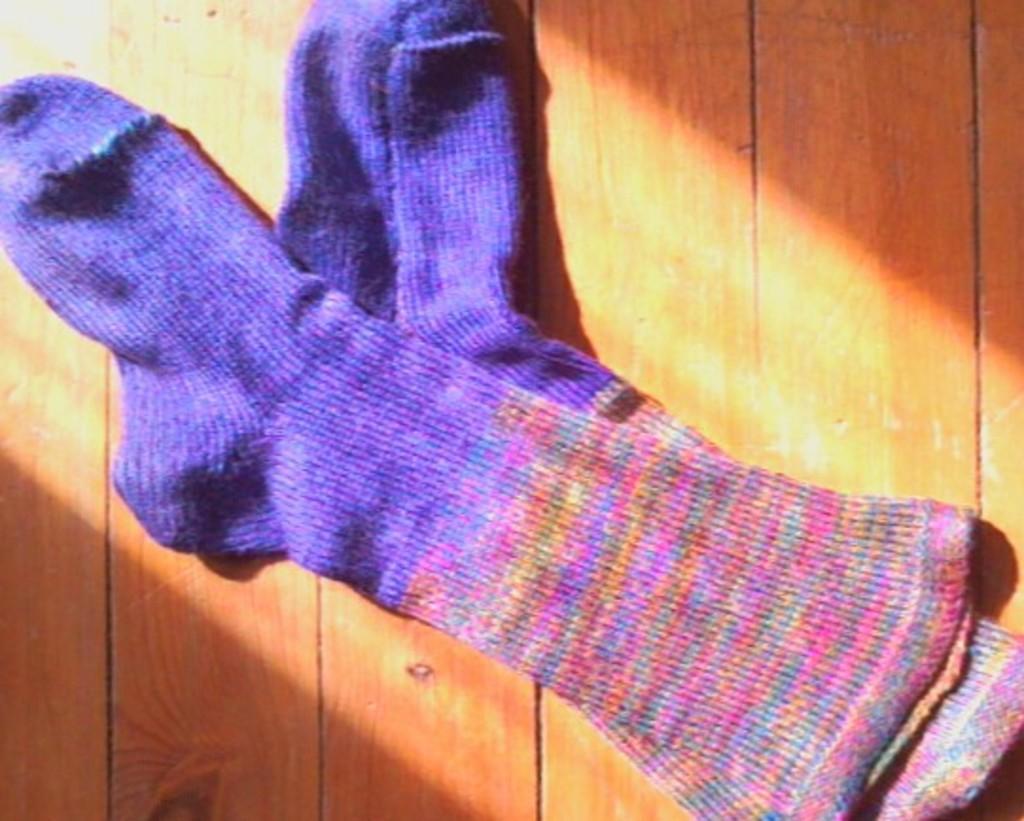How would you summarize this image in a sentence or two? There are two violet and pink color socks on a wooden surface. 